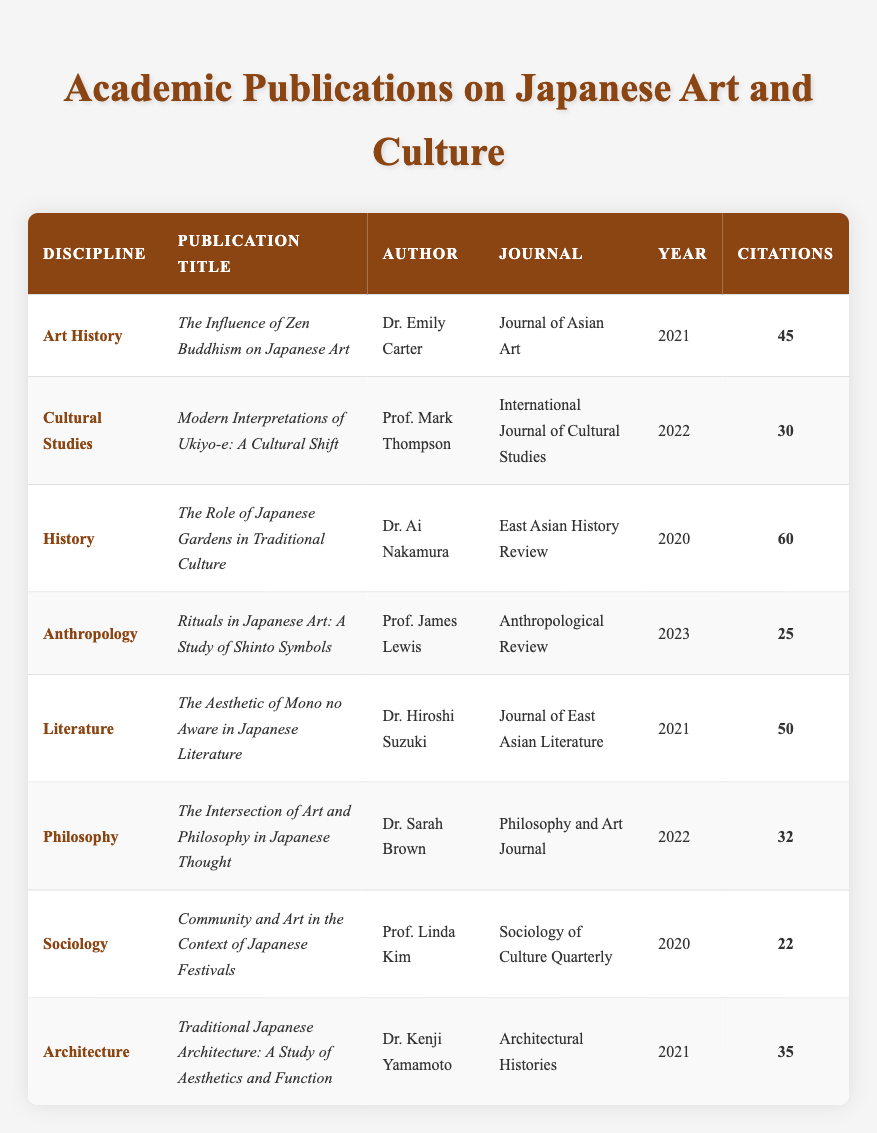What is the most cited publication in the table? The publication with the highest citation number is "The Role of Japanese Gardens in Traditional Culture" by Dr. Ai Nakamura, which has 60 citations.
Answer: "The Role of Japanese Gardens in Traditional Culture" How many publications were released in 2021? There are four publications from the year 2021: "The Influence of Zen Buddhism on Japanese Art," "The Aesthetic of Mono no Aware in Japanese Literature," "Traditional Japanese Architecture: A Study of Aesthetics and Function," and one more.
Answer: 4 Which discipline has the least citations? The publication "Community and Art in the Context of Japanese Festivals" from Sociology has the least citations, with a total of 22. By checking each discipline, Sociology has the lowest citation value.
Answer: Sociology What is the average number of citations for all publications? The total citations of all publications are 60 + 45 + 30 + 50 + 32 + 22 + 35 + 25 = 299. There are 8 publications, so the average is 299 / 8 = 37.375, which can be approximated to 37 when rounded.
Answer: 37 Is there any publication from the discipline of Anthropology? Yes, there is a publication in Anthropology titled "Rituals in Japanese Art: A Study of Shinto Symbols" authored by Prof. James Lewis.
Answer: Yes Which publication focuses on the relationship between art and philosophy? The publication titled "The Intersection of Art and Philosophy in Japanese Thought" by Dr. Sarah Brown discusses the relationship between art and philosophy.
Answer: "The Intersection of Art and Philosophy in Japanese Thought" Which year did the publication with the highest citations appear? The publication with the highest citations, "The Role of Japanese Gardens in Traditional Culture," was published in 2020. By checking the years associated with each publication, 2020 is identified as the year of this highly cited publication.
Answer: 2020 What is the difference in citations between the most cited and least cited publications? The most cited publication has 60 citations, and the least cited publication has 22 citations. The difference is 60 - 22 = 38.
Answer: 38 